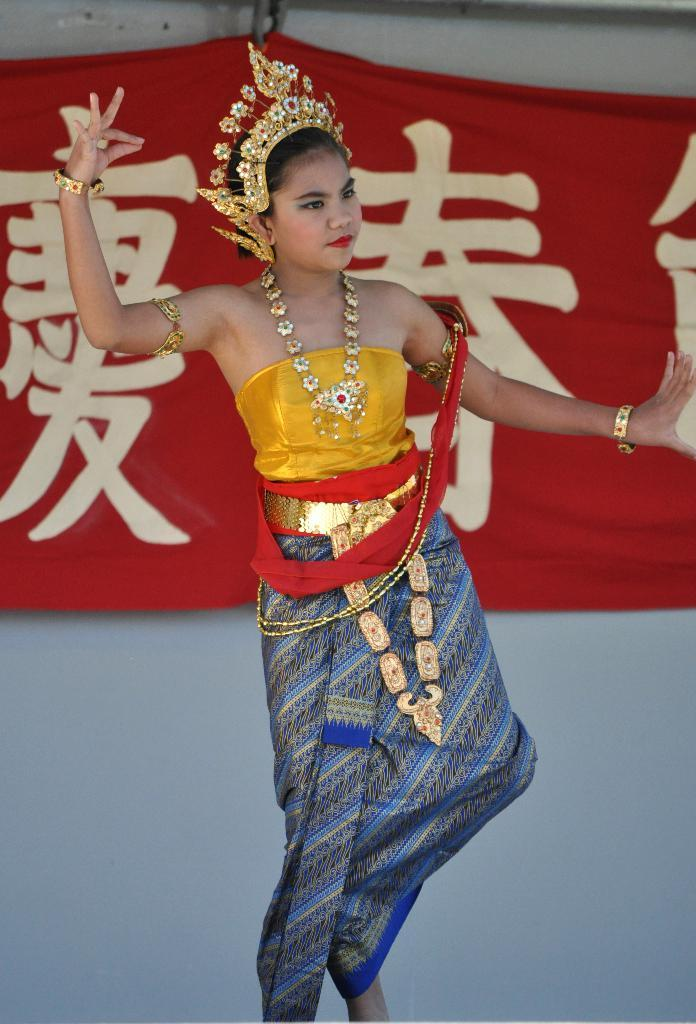Who is the main subject in the image? There is a girl in the image. What is the girl doing in the image? The girl is dancing. What is the girl wearing in the image? The girl is wearing a cultural dress and jewelry. What can be seen in the background of the image? There is a banner in the background of the image. What is written on the banner? There is text written on the banner. What type of silk is being used by the giraffe in the image? There is no giraffe present in the image, and therefore no silk can be associated with it. What is the girl using to carry water in the image? There is no pail or any indication of carrying water in the image. 